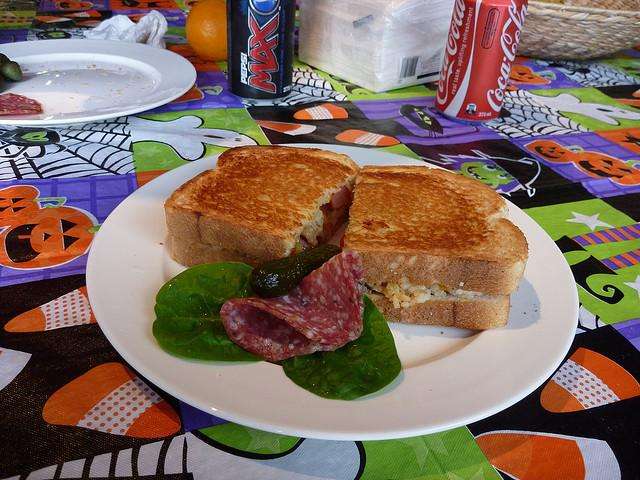What is the side dish?

Choices:
A) pickle
B) fries
C) stuffing
D) carrots pickle 